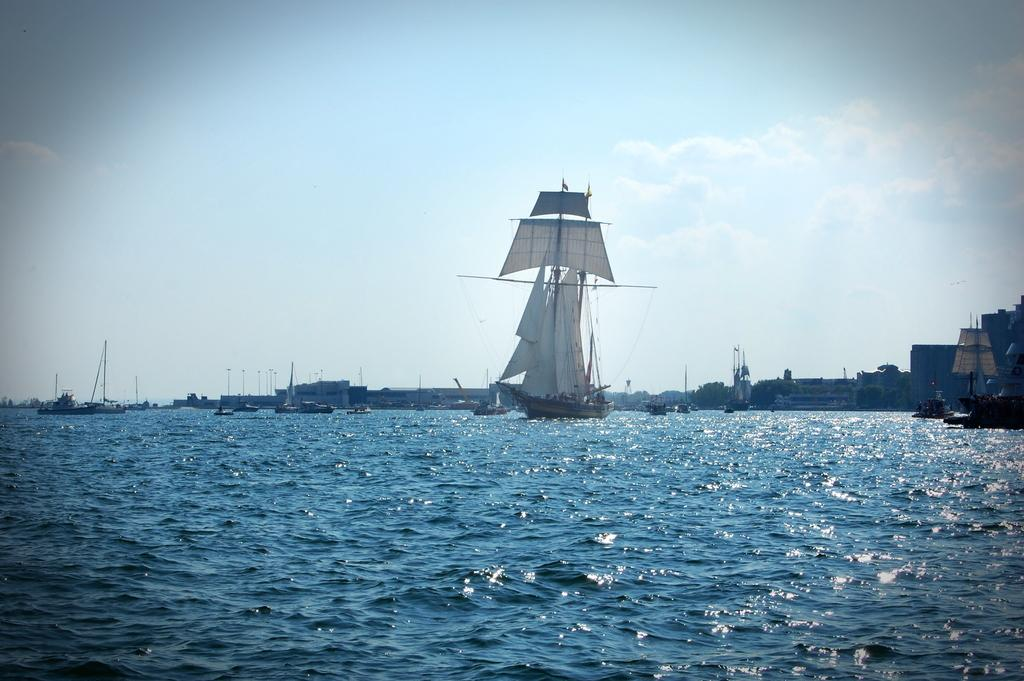What is the main subject of the image? The main subject of the image is ships. Where are the ships located in the image? The ships are on a river in the center of the image. What can be seen in the background of the image? There are buildings and the sky visible in the background of the image. What type of sponge can be seen floating near the ships in the image? There is no sponge visible in the image; it features ships on a river with buildings and the sky in the background. 